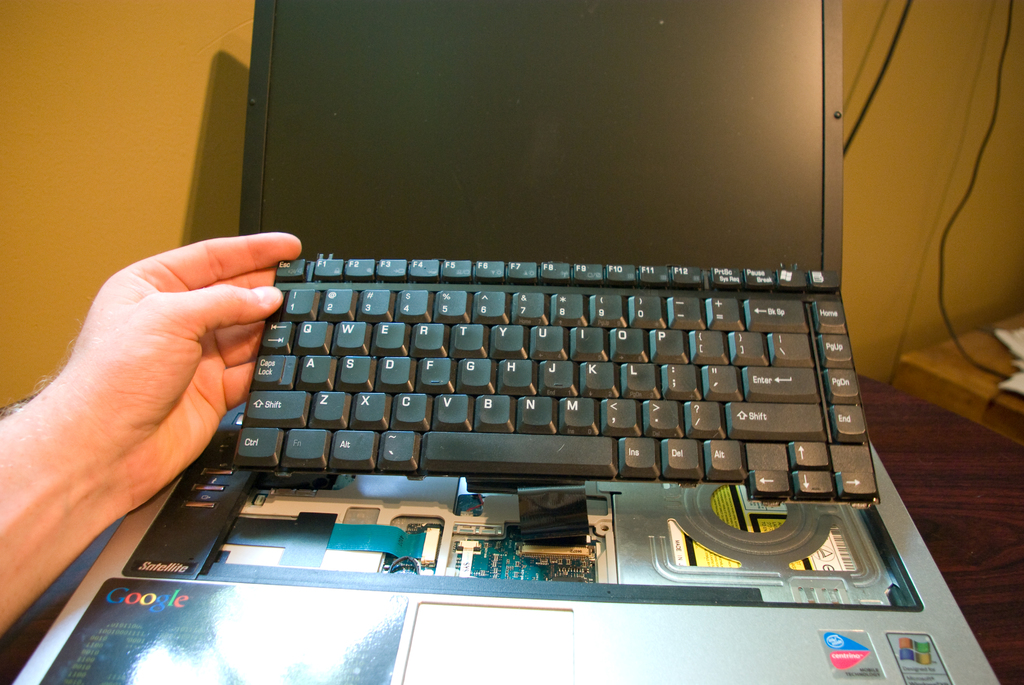Identify the major visible components in this disassembled laptop. The visible components include the keyboard, cooling fan, motherboard, several circuit boards, and wiring. The laptop's screen is also partially visible. 